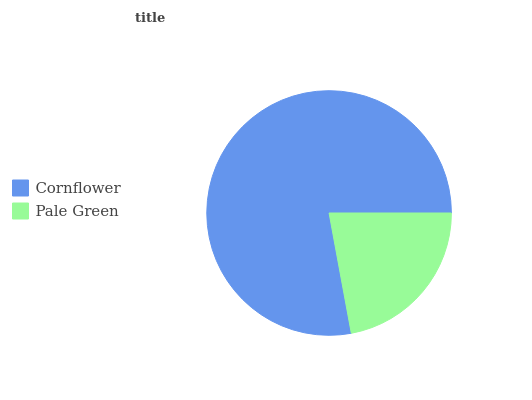Is Pale Green the minimum?
Answer yes or no. Yes. Is Cornflower the maximum?
Answer yes or no. Yes. Is Pale Green the maximum?
Answer yes or no. No. Is Cornflower greater than Pale Green?
Answer yes or no. Yes. Is Pale Green less than Cornflower?
Answer yes or no. Yes. Is Pale Green greater than Cornflower?
Answer yes or no. No. Is Cornflower less than Pale Green?
Answer yes or no. No. Is Cornflower the high median?
Answer yes or no. Yes. Is Pale Green the low median?
Answer yes or no. Yes. Is Pale Green the high median?
Answer yes or no. No. Is Cornflower the low median?
Answer yes or no. No. 